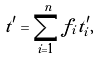Convert formula to latex. <formula><loc_0><loc_0><loc_500><loc_500>t ^ { \prime } = \sum _ { i = 1 } ^ { n } f _ { i } t _ { i } ^ { \prime } ,</formula> 